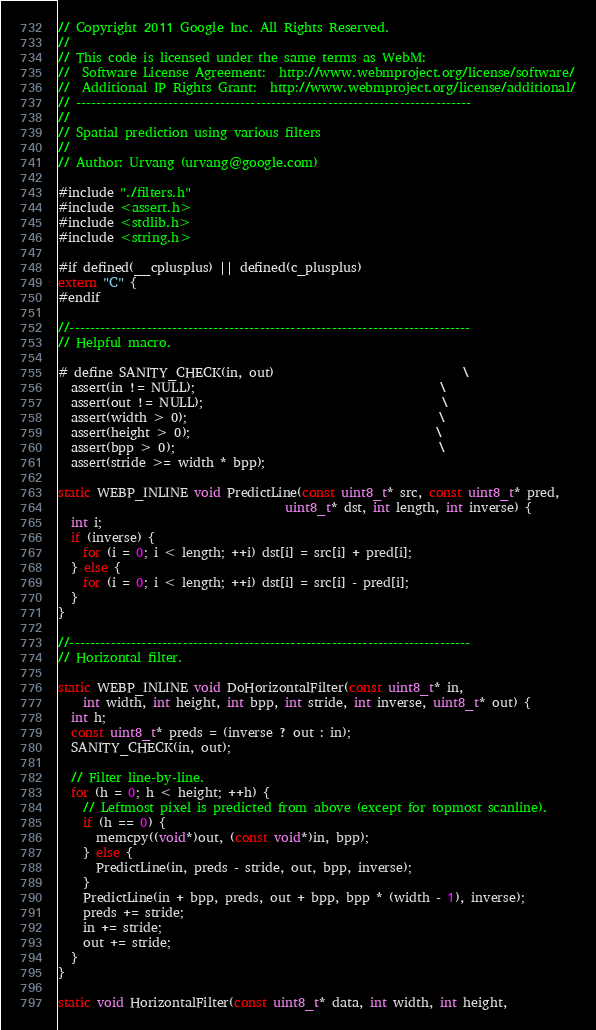<code> <loc_0><loc_0><loc_500><loc_500><_C_>// Copyright 2011 Google Inc. All Rights Reserved.
//
// This code is licensed under the same terms as WebM:
//  Software License Agreement:  http://www.webmproject.org/license/software/
//  Additional IP Rights Grant:  http://www.webmproject.org/license/additional/
// -----------------------------------------------------------------------------
//
// Spatial prediction using various filters
//
// Author: Urvang (urvang@google.com)

#include "./filters.h"
#include <assert.h>
#include <stdlib.h>
#include <string.h>

#if defined(__cplusplus) || defined(c_plusplus)
extern "C" {
#endif

//------------------------------------------------------------------------------
// Helpful macro.

# define SANITY_CHECK(in, out)                              \
  assert(in != NULL);                                       \
  assert(out != NULL);                                      \
  assert(width > 0);                                        \
  assert(height > 0);                                       \
  assert(bpp > 0);                                          \
  assert(stride >= width * bpp);

static WEBP_INLINE void PredictLine(const uint8_t* src, const uint8_t* pred,
                                    uint8_t* dst, int length, int inverse) {
  int i;
  if (inverse) {
    for (i = 0; i < length; ++i) dst[i] = src[i] + pred[i];
  } else {
    for (i = 0; i < length; ++i) dst[i] = src[i] - pred[i];
  }
}

//------------------------------------------------------------------------------
// Horizontal filter.

static WEBP_INLINE void DoHorizontalFilter(const uint8_t* in,
    int width, int height, int bpp, int stride, int inverse, uint8_t* out) {
  int h;
  const uint8_t* preds = (inverse ? out : in);
  SANITY_CHECK(in, out);

  // Filter line-by-line.
  for (h = 0; h < height; ++h) {
    // Leftmost pixel is predicted from above (except for topmost scanline).
    if (h == 0) {
      memcpy((void*)out, (const void*)in, bpp);
    } else {
      PredictLine(in, preds - stride, out, bpp, inverse);
    }
    PredictLine(in + bpp, preds, out + bpp, bpp * (width - 1), inverse);
    preds += stride;
    in += stride;
    out += stride;
  }
}

static void HorizontalFilter(const uint8_t* data, int width, int height,</code> 